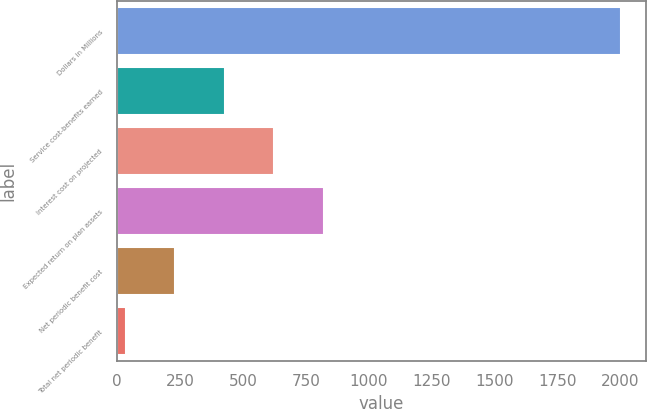Convert chart to OTSL. <chart><loc_0><loc_0><loc_500><loc_500><bar_chart><fcel>Dollars in Millions<fcel>Service cost-benefits earned<fcel>Interest cost on projected<fcel>Expected return on plan assets<fcel>Net periodic benefit cost<fcel>Total net periodic benefit<nl><fcel>2002<fcel>427.6<fcel>624.4<fcel>821.2<fcel>230.8<fcel>34<nl></chart> 